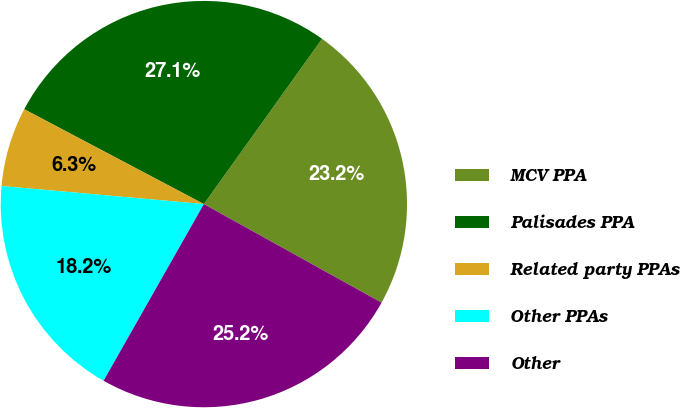Convert chart to OTSL. <chart><loc_0><loc_0><loc_500><loc_500><pie_chart><fcel>MCV PPA<fcel>Palisades PPA<fcel>Related party PPAs<fcel>Other PPAs<fcel>Other<nl><fcel>23.18%<fcel>27.15%<fcel>6.31%<fcel>18.2%<fcel>25.16%<nl></chart> 